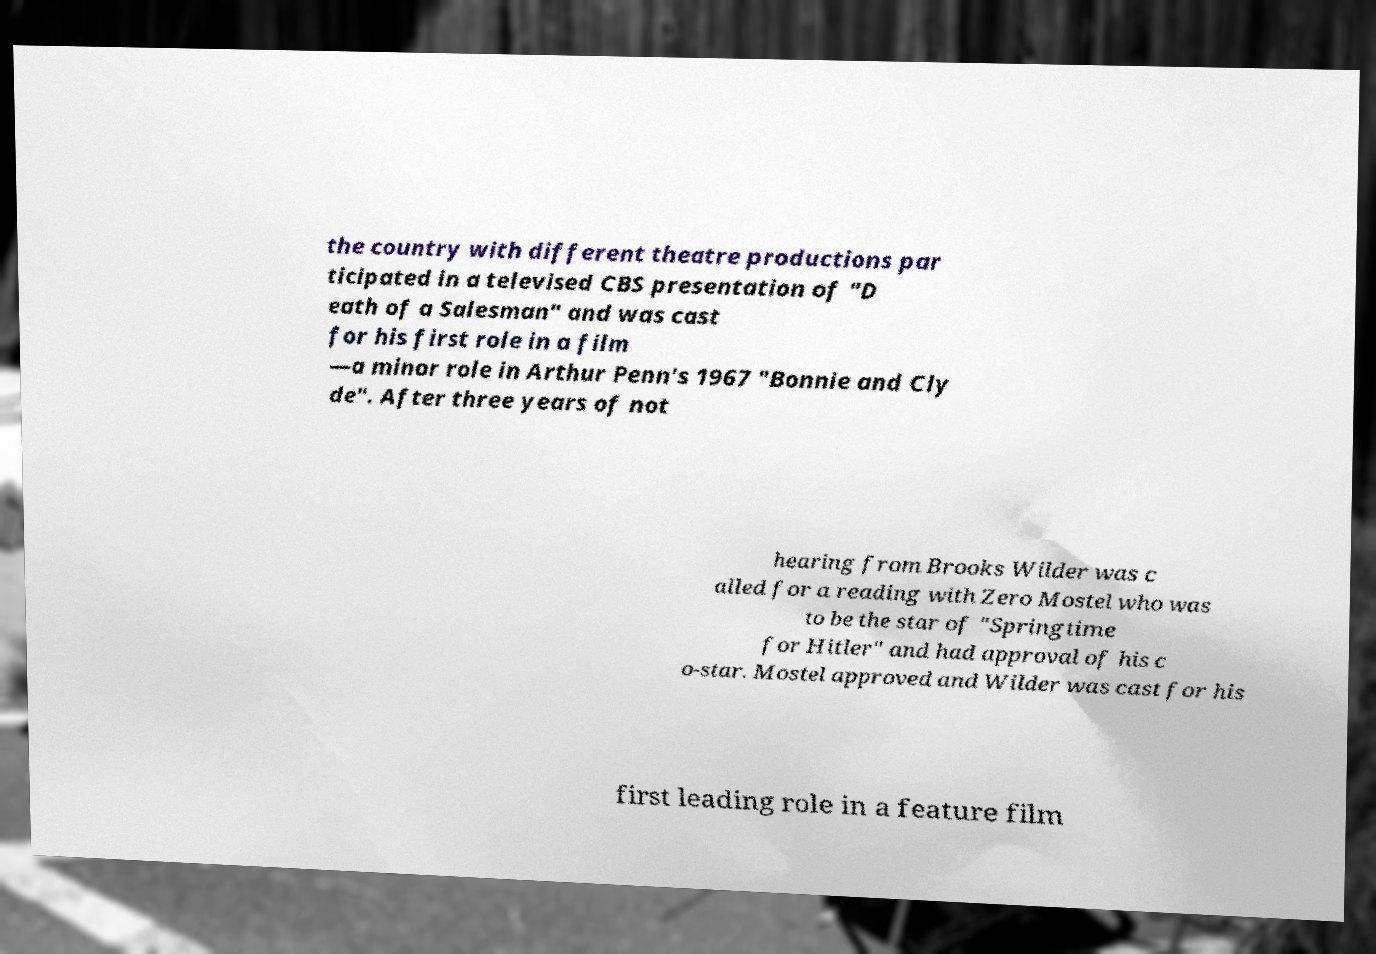There's text embedded in this image that I need extracted. Can you transcribe it verbatim? the country with different theatre productions par ticipated in a televised CBS presentation of "D eath of a Salesman" and was cast for his first role in a film —a minor role in Arthur Penn's 1967 "Bonnie and Cly de". After three years of not hearing from Brooks Wilder was c alled for a reading with Zero Mostel who was to be the star of "Springtime for Hitler" and had approval of his c o-star. Mostel approved and Wilder was cast for his first leading role in a feature film 